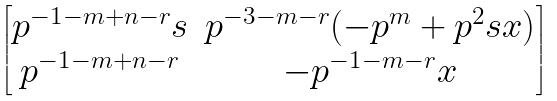Convert formula to latex. <formula><loc_0><loc_0><loc_500><loc_500>\begin{bmatrix} p ^ { - 1 - m + n - r } s & p ^ { - 3 - m - r } ( - p ^ { m } + p ^ { 2 } s x ) \\ p ^ { - 1 - m + n - r } & - p ^ { - 1 - m - r } x \end{bmatrix}</formula> 